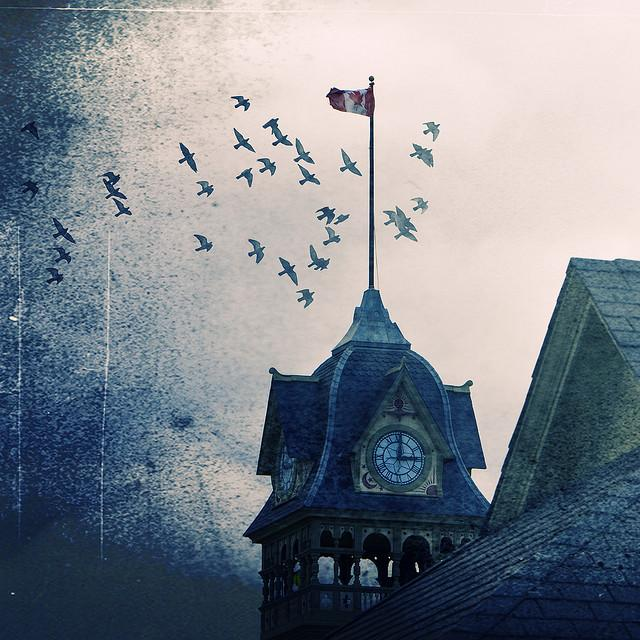What nation's flag are the birds flying towards? canada 